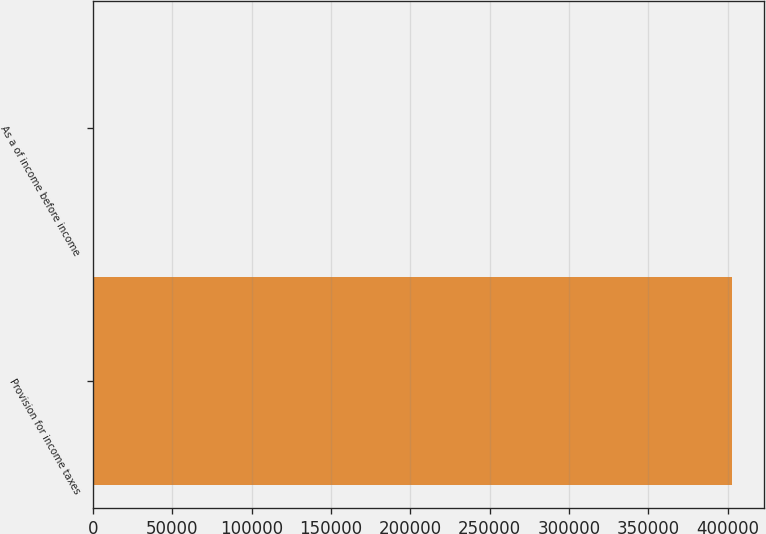<chart> <loc_0><loc_0><loc_500><loc_500><bar_chart><fcel>Provision for income taxes<fcel>As a of income before income<nl><fcel>402600<fcel>54<nl></chart> 